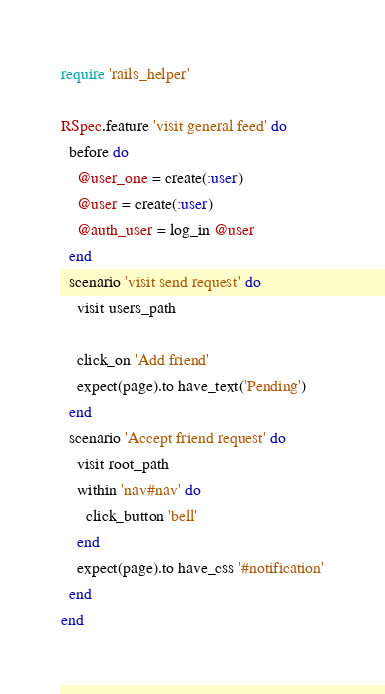Convert code to text. <code><loc_0><loc_0><loc_500><loc_500><_Ruby_>require 'rails_helper'

RSpec.feature 'visit general feed' do
  before do
    @user_one = create(:user)
    @user = create(:user)
    @auth_user = log_in @user
  end
  scenario 'visit send request' do
    visit users_path

    click_on 'Add friend'
    expect(page).to have_text('Pending')
  end
  scenario 'Accept friend request' do
    visit root_path
    within 'nav#nav' do
      click_button 'bell'
    end
    expect(page).to have_css '#notification'
  end
end
</code> 